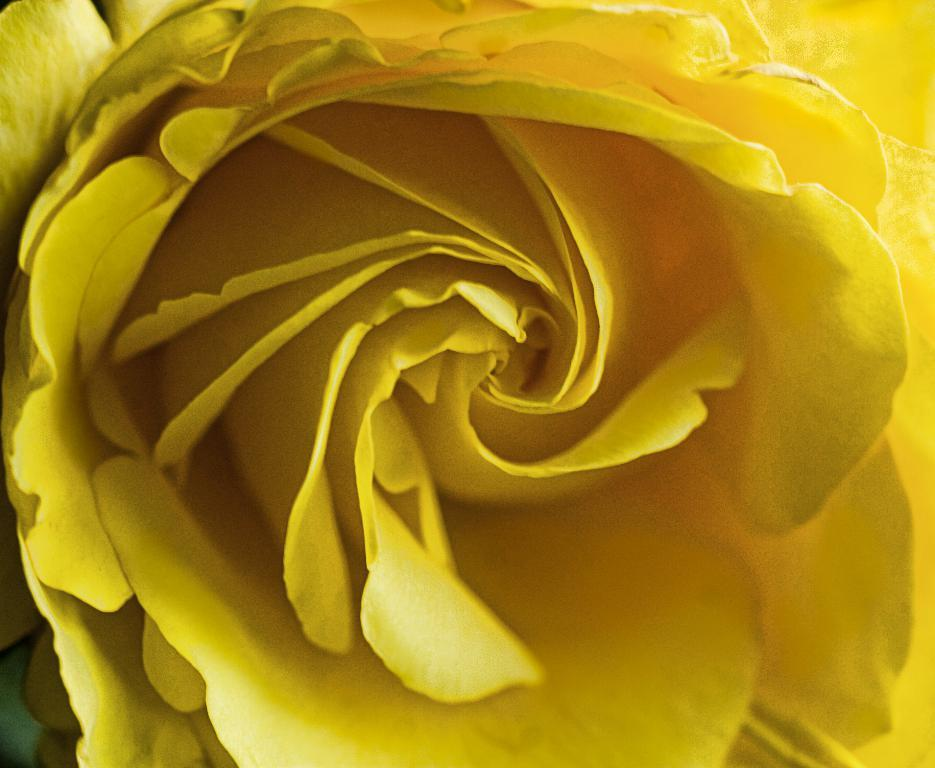What is the main subject of the image? There is a flower in the image. Can you describe the color of the flower? The flower is yellow in color. What type of cake is being served to the family in the image? There is no cake or family present in the image; it only features a yellow flower. 